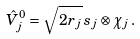Convert formula to latex. <formula><loc_0><loc_0><loc_500><loc_500>\hat { V } ^ { 0 } _ { j } = \sqrt { 2 r _ { j } } \, s _ { j } \otimes \chi _ { j } \, .</formula> 